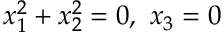<formula> <loc_0><loc_0><loc_500><loc_500>x _ { 1 } ^ { 2 } + x _ { 2 } ^ { 2 } = 0 , \ x _ { 3 } = 0</formula> 